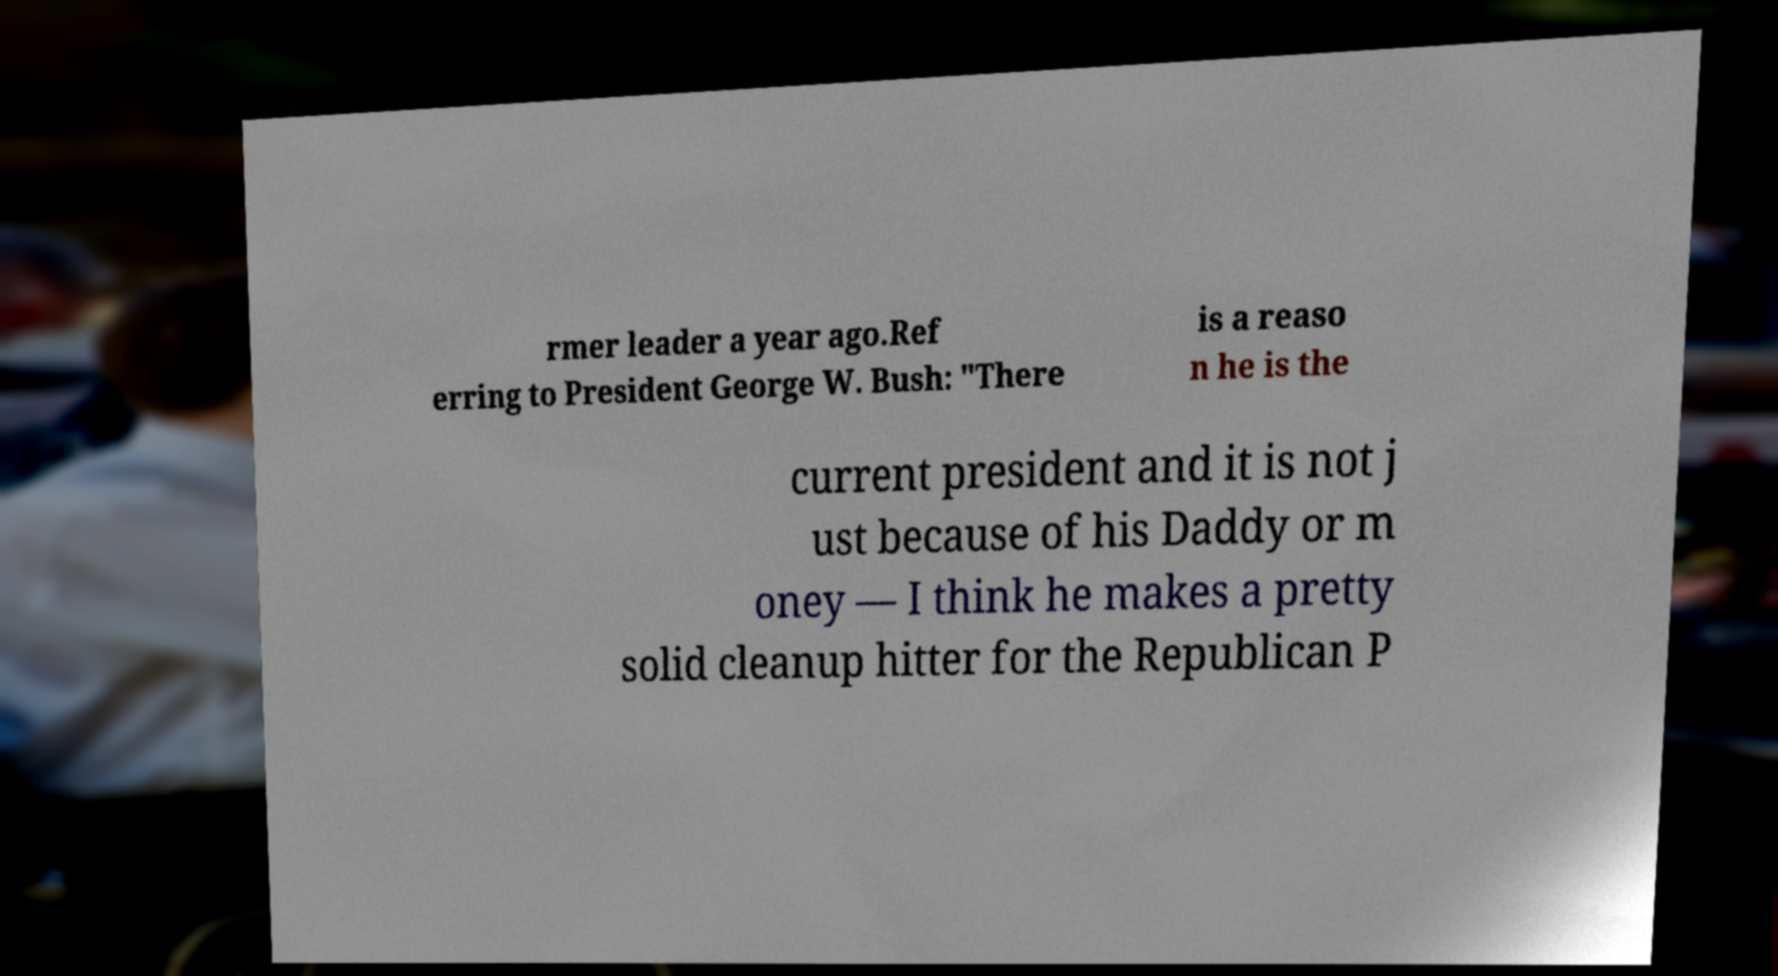I need the written content from this picture converted into text. Can you do that? rmer leader a year ago.Ref erring to President George W. Bush: "There is a reaso n he is the current president and it is not j ust because of his Daddy or m oney — I think he makes a pretty solid cleanup hitter for the Republican P 